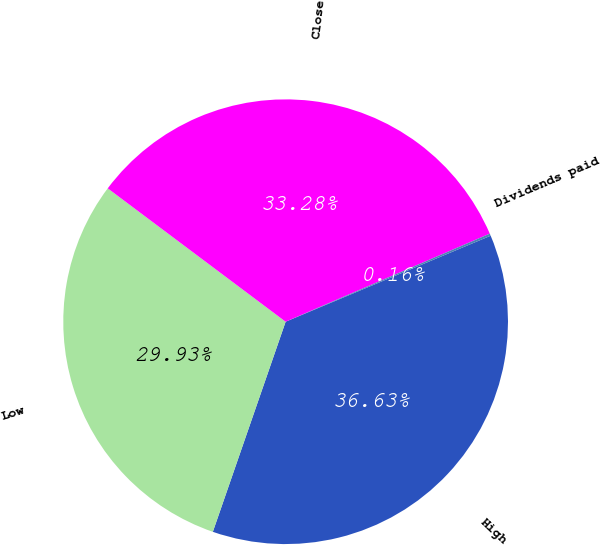Convert chart to OTSL. <chart><loc_0><loc_0><loc_500><loc_500><pie_chart><fcel>High<fcel>Low<fcel>Close<fcel>Dividends paid<nl><fcel>36.63%<fcel>29.93%<fcel>33.28%<fcel>0.16%<nl></chart> 